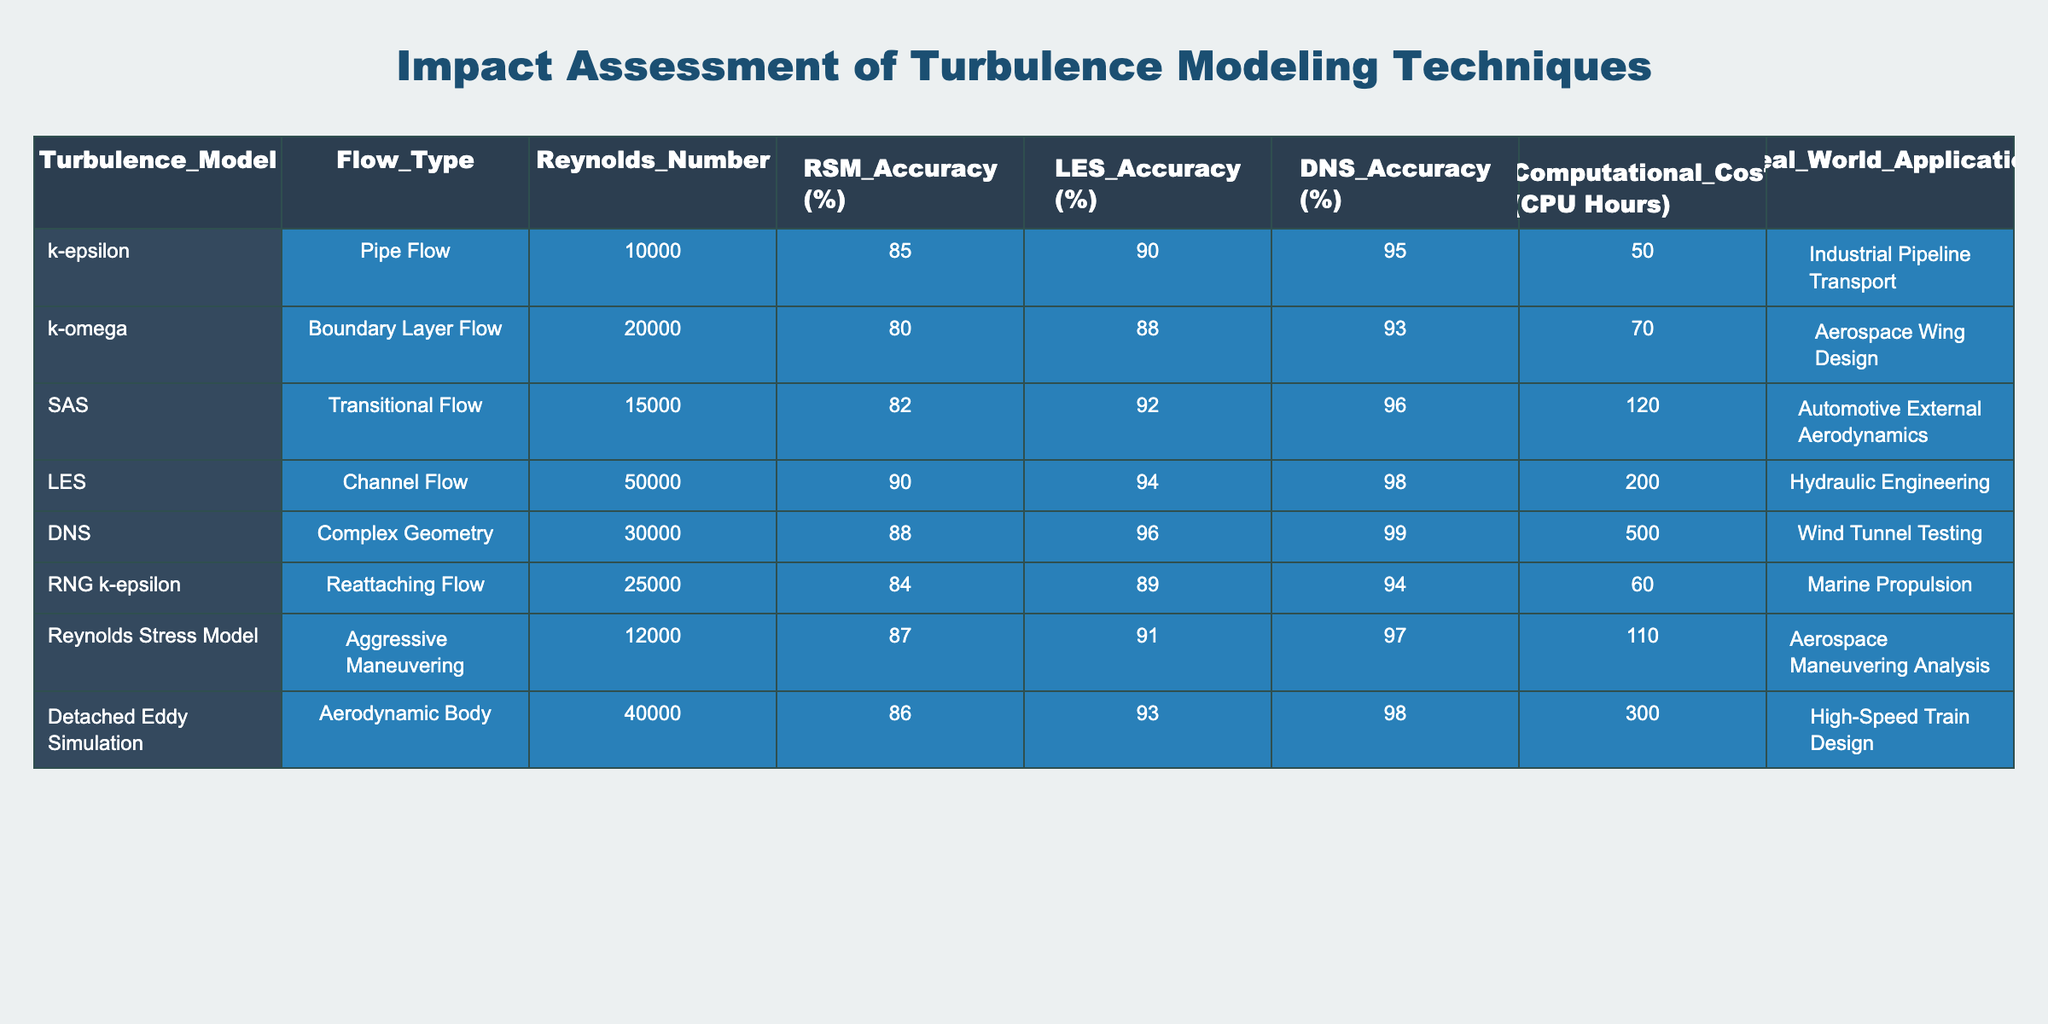What is the accuracy percentage for the k-epsilon turbulence model in pipe flow? The table shows the RSM Accuracy (%) value for the k-epsilon model in the pipe flow category, which is 85%.
Answer: 85% What is the computational cost in CPU hours for the k-omega model? The k-omega model has a computational cost listed in the table, which is 70 CPU hours.
Answer: 70 CPU hours Which turbulence model has the highest DNS accuracy percentage? By comparing the DNS accuracy percentages in the table, the model with the highest value is DNS, which has a DNS Accuracy (%) of 99%.
Answer: 99% What is the average RSM accuracy of the turbulence models listed? To find the average RSM accuracy, add the RSM accuracy percentages (85 + 80 + 82 + 90 + 88 + 84 + 87 + 86) = 692 and then divide by the number of models (8). The average is 692/8 = 86.5%.
Answer: 86.5% Does the Detached Eddy Simulation have a higher LES accuracy than the Reynolds Stress Model? The table shows that the Detached Eddy Simulation has an LES Accuracy (%) of 93%, while the Reynolds Stress Model's LES accuracy is 91%. Therefore, yes, the Detached Eddy Simulation has a higher LES accuracy.
Answer: Yes What is the difference in the computational cost between DNS and LES models? The computational cost for DNS is 500 CPU hours, and for LES, it is 200 CPU hours. Calculating the difference gives us 500 - 200 = 300 CPU hours.
Answer: 300 CPU hours Which model has the lowest RSM accuracy, and what is that accuracy? By checking the RSM accuracy values in the table, the model with the lowest RSM accuracy is the k-omega model, which has an RSM accuracy of 80%.
Answer: k-omega, 80% What is the sum of the Reynolds numbers for all models in the table? The Reynolds numbers listed are 10000, 20000, 15000, 50000, 30000, 25000, 12000, and 40000. Summing these values gives 10000 + 20000 + 15000 + 50000 + 30000 + 25000 + 12000 + 40000 = 202000.
Answer: 202000 In real-world applications, which model is used for hydraulic engineering? The table indicates that the LES model is used for hydraulic engineering as its real-world application is listed there.
Answer: LES Is there a turbulence model that has both high RSM accuracy and low computational cost? The models with RSM accuracy above 85% include k-epsilon (85%, 50 CPU hours), RNG k-epsilon (84%, 60 CPU hours), and Detached Eddy Simulation (86%, 300 CPU hours). The k-epsilon model has the highest RSM accuracy (85%) and the lowest computational cost (50 CPU hours). Thus, yes, the k-epsilon model meets these criteria.
Answer: Yes, k-epsilon 